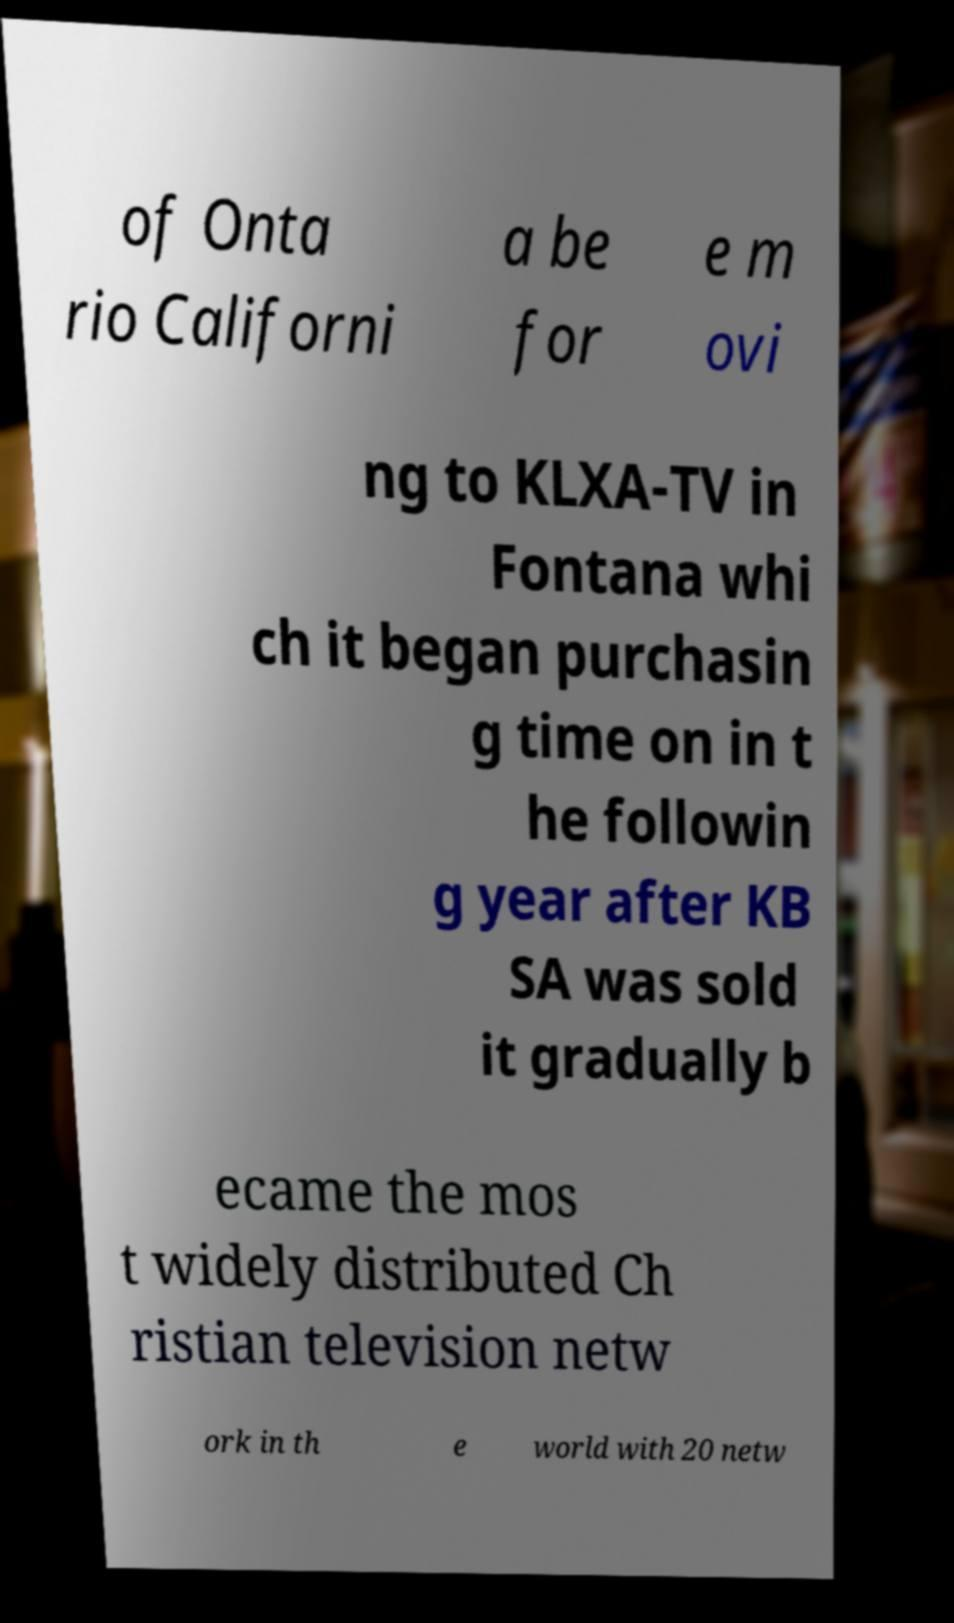Can you read and provide the text displayed in the image?This photo seems to have some interesting text. Can you extract and type it out for me? of Onta rio Californi a be for e m ovi ng to KLXA-TV in Fontana whi ch it began purchasin g time on in t he followin g year after KB SA was sold it gradually b ecame the mos t widely distributed Ch ristian television netw ork in th e world with 20 netw 